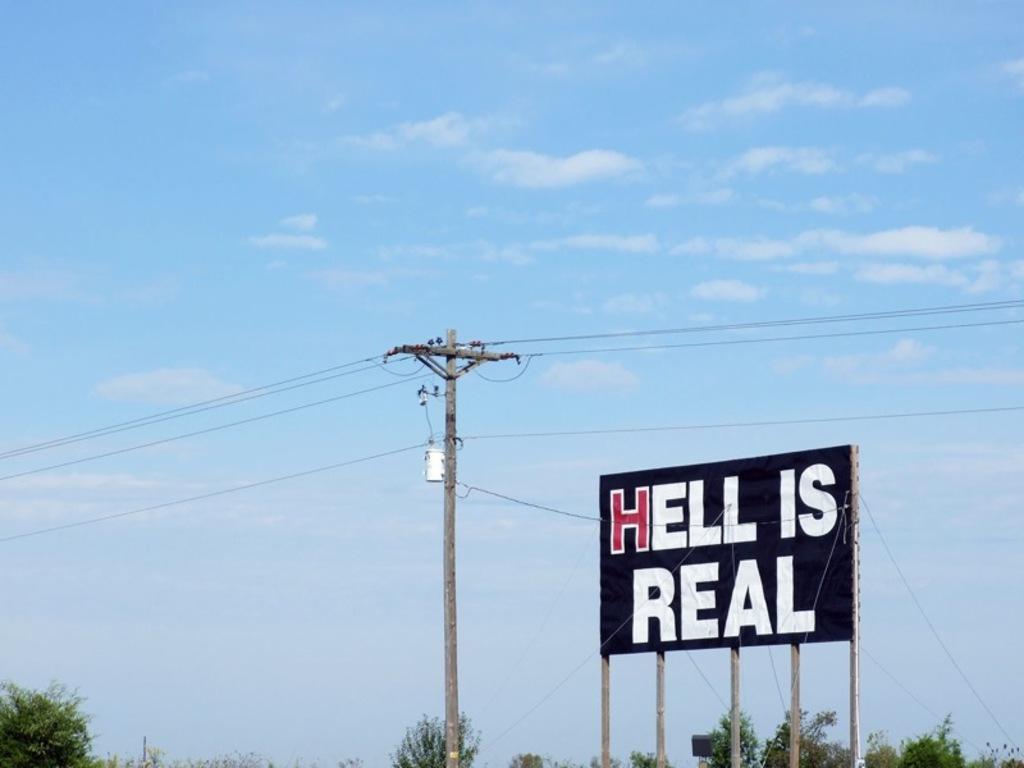What is real according to the sign?
Your response must be concise. Hell. Does this sign think hell is real?
Offer a terse response. Yes. 